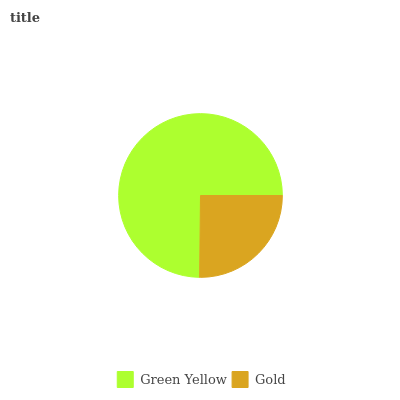Is Gold the minimum?
Answer yes or no. Yes. Is Green Yellow the maximum?
Answer yes or no. Yes. Is Gold the maximum?
Answer yes or no. No. Is Green Yellow greater than Gold?
Answer yes or no. Yes. Is Gold less than Green Yellow?
Answer yes or no. Yes. Is Gold greater than Green Yellow?
Answer yes or no. No. Is Green Yellow less than Gold?
Answer yes or no. No. Is Green Yellow the high median?
Answer yes or no. Yes. Is Gold the low median?
Answer yes or no. Yes. Is Gold the high median?
Answer yes or no. No. Is Green Yellow the low median?
Answer yes or no. No. 